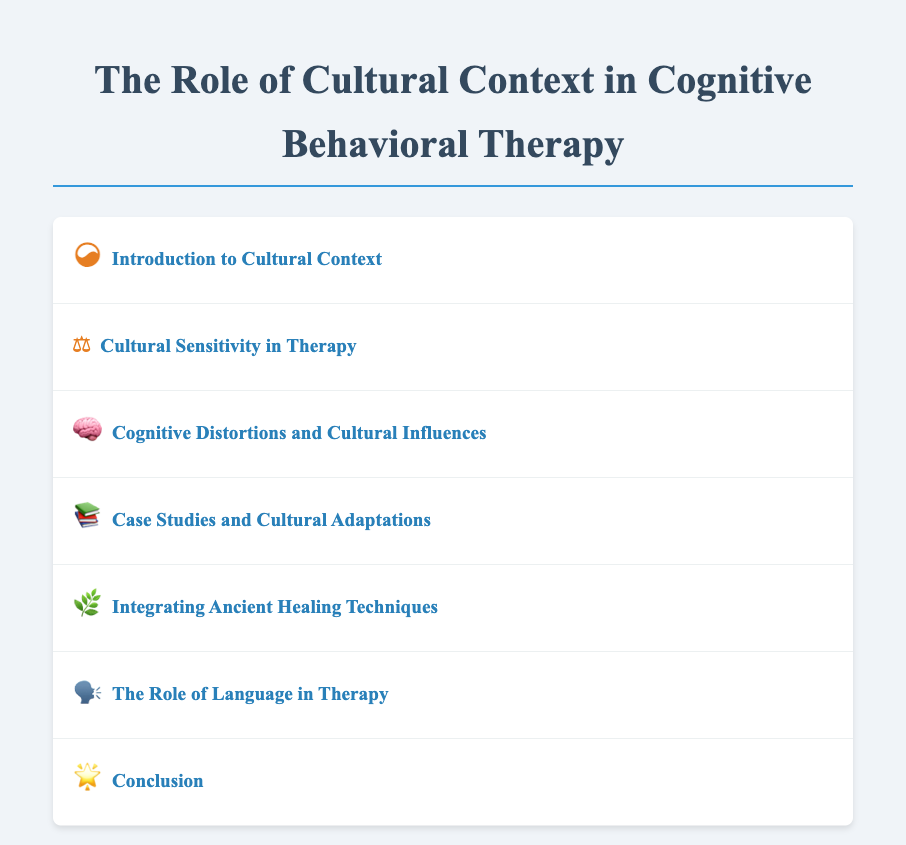What is the title of the document? The title is presented prominently at the top of the document.
Answer: The Role of Cultural Context in Cognitive Behavioral Therapy What does the ancient symbol in the introduction represent? The ancient symbol denotes the thematic element explored in the introduction section.
Answer: ☯ What are therapists required to practice according to the cultural sensitivity section? This section specifies the essential practice for therapists regarding their approach to cultural issues.
Answer: Cultural sensitivity Which cognitive distortion is mentioned in relation to collectivist societies? This distortion is specifically linked to how individuals in collectivist cultures may perceive situations.
Answer: Group-oriented distortions What is one ancient healing technique mentioned that can complement CBT? This technique is highlighted as a practice that has roots in ancient traditions and can enhance therapy.
Answer: Mindfulness How many menu items are listed in the document? The total number of menu items is counted across all sections provided.
Answer: Six What is the overarching theme discussed in the conclusion? The conclusion summarizes the core idea presented throughout the document.
Answer: Cultural context in therapy 